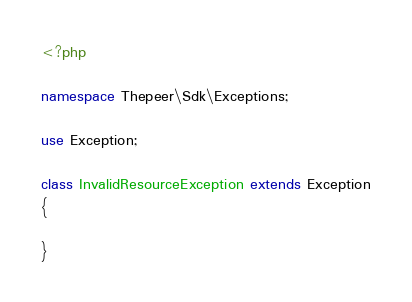Convert code to text. <code><loc_0><loc_0><loc_500><loc_500><_PHP_><?php

namespace Thepeer\Sdk\Exceptions;

use Exception;

class InvalidResourceException extends Exception
{

}</code> 